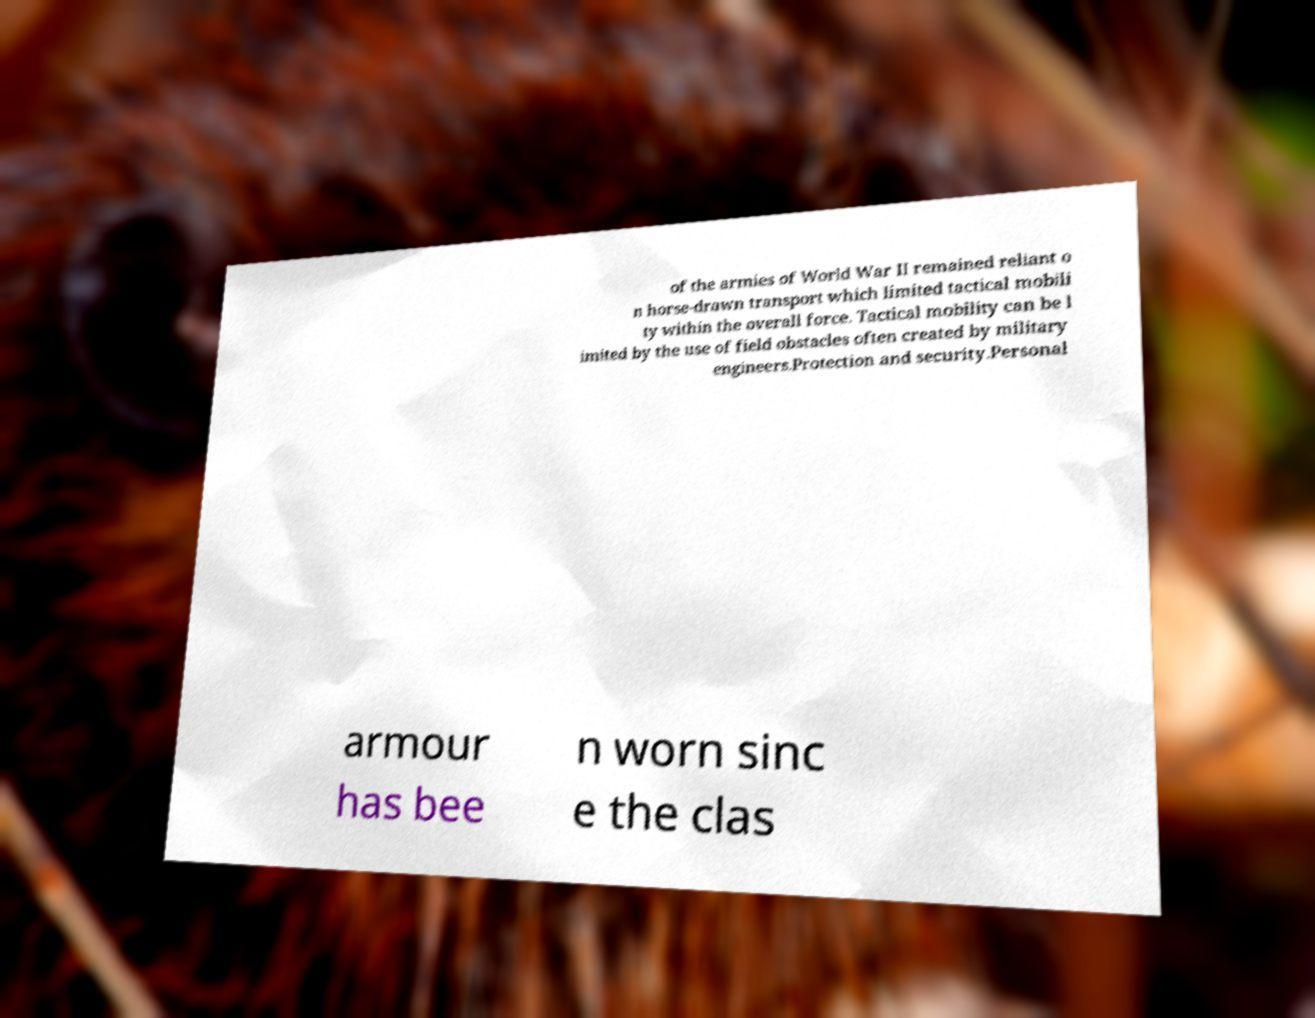Can you accurately transcribe the text from the provided image for me? of the armies of World War II remained reliant o n horse-drawn transport which limited tactical mobili ty within the overall force. Tactical mobility can be l imited by the use of field obstacles often created by military engineers.Protection and security.Personal armour has bee n worn sinc e the clas 